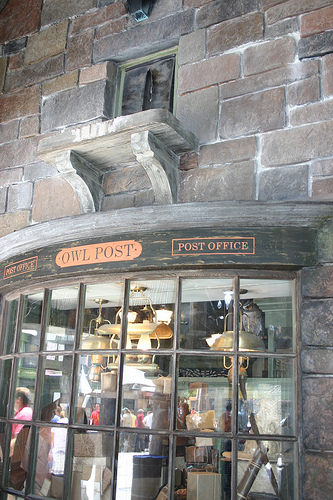<image>
Can you confirm if the post office is on the wood? Yes. Looking at the image, I can see the post office is positioned on top of the wood, with the wood providing support. 